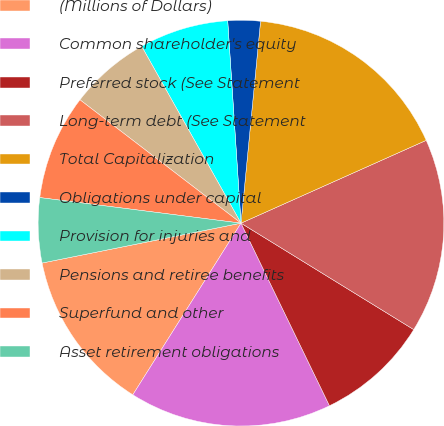Convert chart. <chart><loc_0><loc_0><loc_500><loc_500><pie_chart><fcel>(Millions of Dollars)<fcel>Common shareholder's equity<fcel>Preferred stock (See Statement<fcel>Long-term debt (See Statement<fcel>Total Capitalization<fcel>Obligations under capital<fcel>Provision for injuries and<fcel>Pensions and retiree benefits<fcel>Superfund and other<fcel>Asset retirement obligations<nl><fcel>12.9%<fcel>16.13%<fcel>9.03%<fcel>15.48%<fcel>16.77%<fcel>2.58%<fcel>7.1%<fcel>6.45%<fcel>8.39%<fcel>5.16%<nl></chart> 